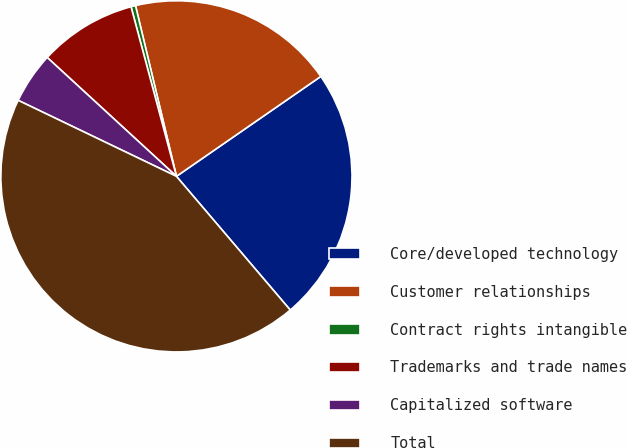Convert chart to OTSL. <chart><loc_0><loc_0><loc_500><loc_500><pie_chart><fcel>Core/developed technology<fcel>Customer relationships<fcel>Contract rights intangible<fcel>Trademarks and trade names<fcel>Capitalized software<fcel>Total<nl><fcel>23.41%<fcel>19.11%<fcel>0.42%<fcel>9.0%<fcel>4.71%<fcel>43.35%<nl></chart> 